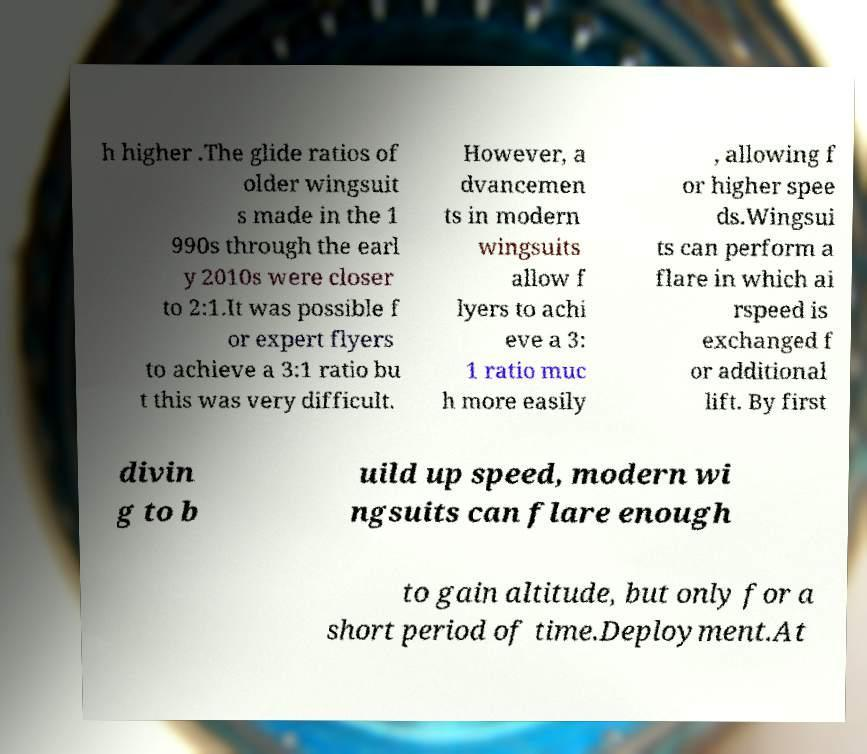Please identify and transcribe the text found in this image. h higher .The glide ratios of older wingsuit s made in the 1 990s through the earl y 2010s were closer to 2:1.It was possible f or expert flyers to achieve a 3:1 ratio bu t this was very difficult. However, a dvancemen ts in modern wingsuits allow f lyers to achi eve a 3: 1 ratio muc h more easily , allowing f or higher spee ds.Wingsui ts can perform a flare in which ai rspeed is exchanged f or additional lift. By first divin g to b uild up speed, modern wi ngsuits can flare enough to gain altitude, but only for a short period of time.Deployment.At 